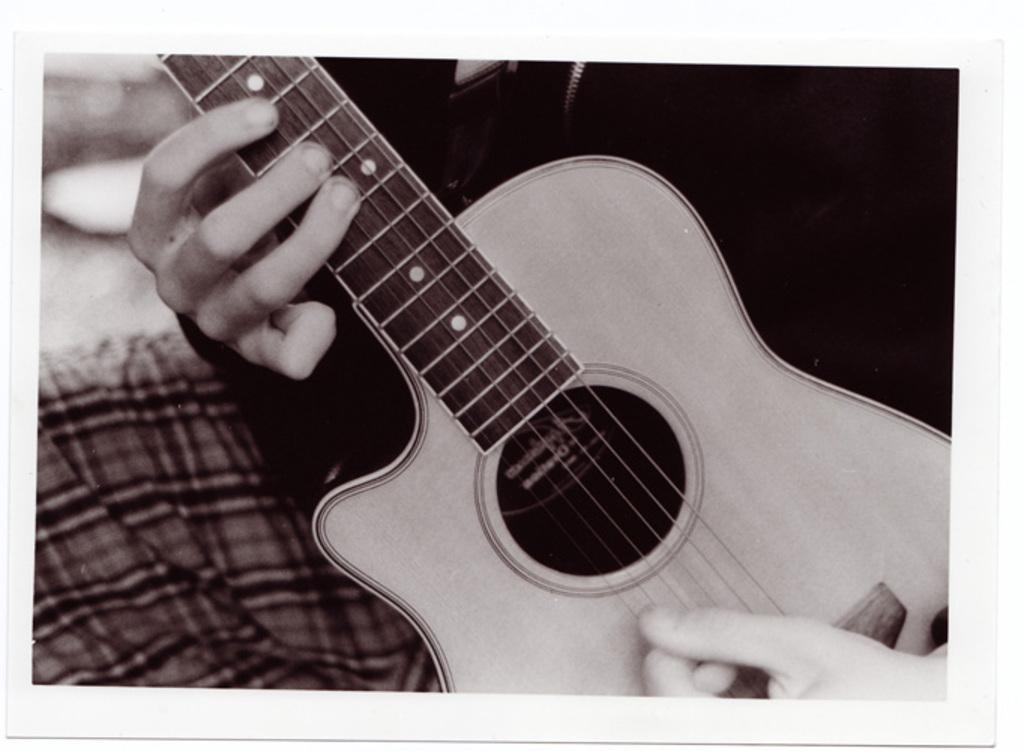What is the main subject of the image? There is a person in the image. What is the person holding in the image? The person is holding a guitar. What is the person doing with the guitar? The person is playing the guitar. How many chairs are visible in the image? There are no chairs visible in the image; it only features a person playing a guitar. 